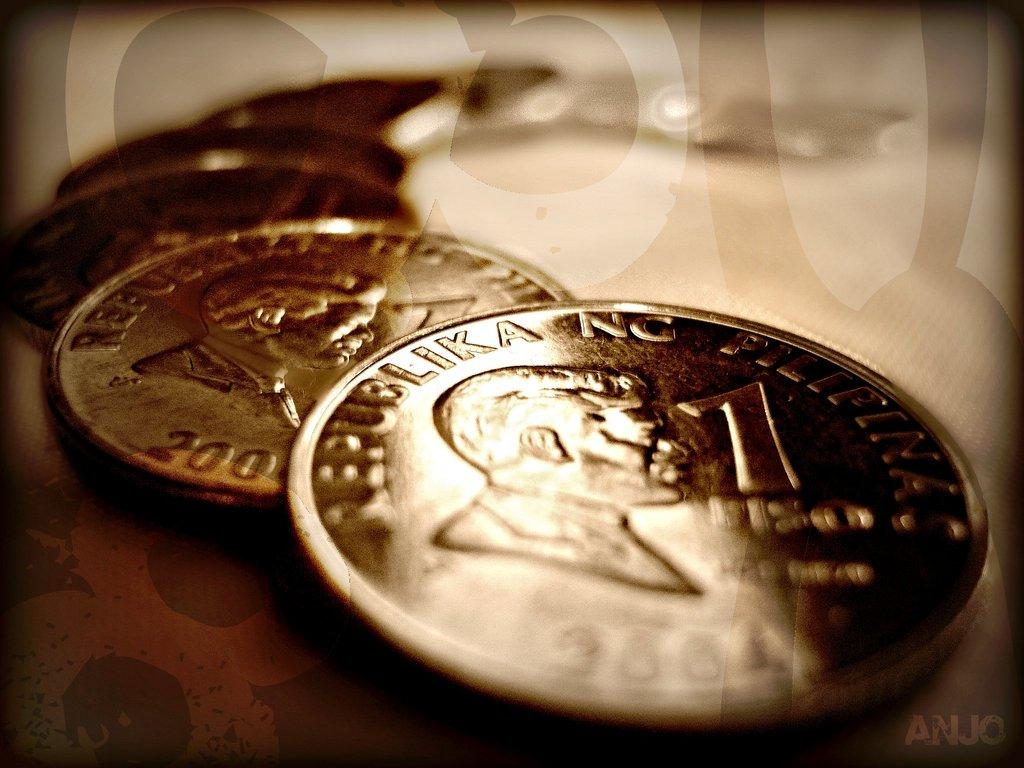How much money are those worth?
Offer a terse response. 1. 